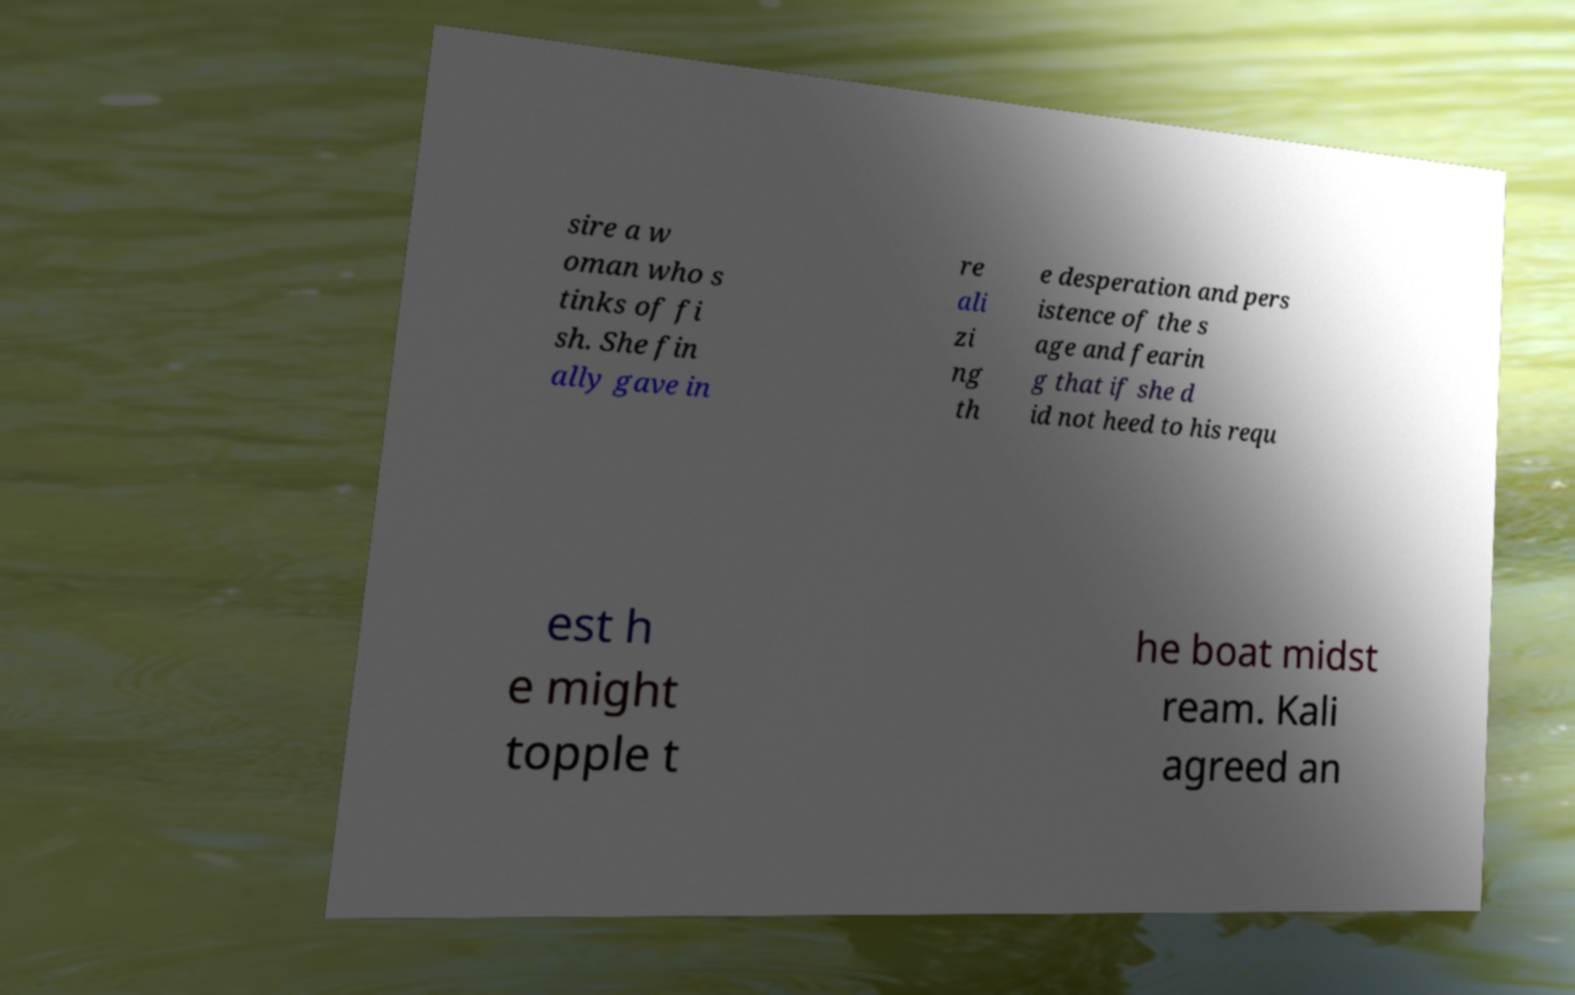Can you accurately transcribe the text from the provided image for me? sire a w oman who s tinks of fi sh. She fin ally gave in re ali zi ng th e desperation and pers istence of the s age and fearin g that if she d id not heed to his requ est h e might topple t he boat midst ream. Kali agreed an 